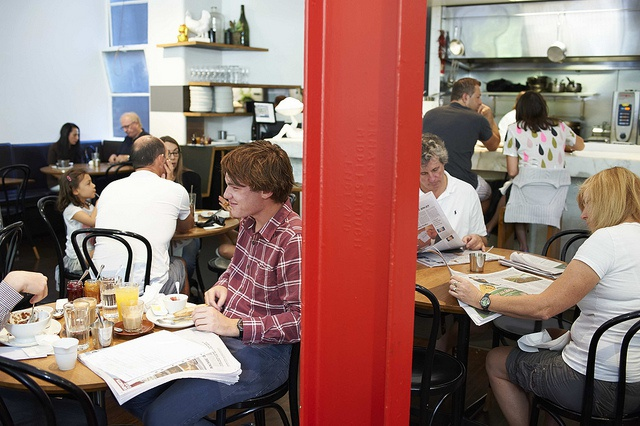Describe the objects in this image and their specific colors. I can see people in lightgray, black, darkgray, and tan tones, people in lightgray, navy, brown, maroon, and black tones, people in lightgray, white, black, gray, and darkgray tones, dining table in lightgray, tan, and darkgray tones, and chair in lightgray, black, and darkgray tones in this image. 